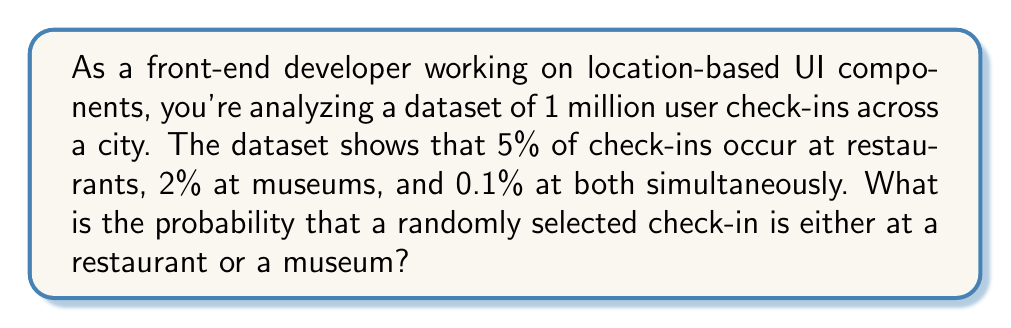Could you help me with this problem? Let's approach this step-by-step using probability theory:

1) Let's define our events:
   R: Check-in at a restaurant
   M: Check-in at a museum

2) We're given the following probabilities:
   $P(R) = 0.05$ (5% of check-ins are at restaurants)
   $P(M) = 0.02$ (2% of check-ins are at museums)
   $P(R \cap M) = 0.001$ (0.1% of check-ins are at both)

3) We need to find $P(R \cup M)$, the probability of a check-in being at either a restaurant or a museum (or both).

4) We can use the addition rule of probability:
   $P(R \cup M) = P(R) + P(M) - P(R \cap M)$

5) Substituting our known values:
   $P(R \cup M) = 0.05 + 0.02 - 0.001$

6) Calculating:
   $P(R \cup M) = 0.069$

Therefore, the probability of a randomly selected check-in being either at a restaurant or a museum is 0.069 or 6.9%.
Answer: 0.069 